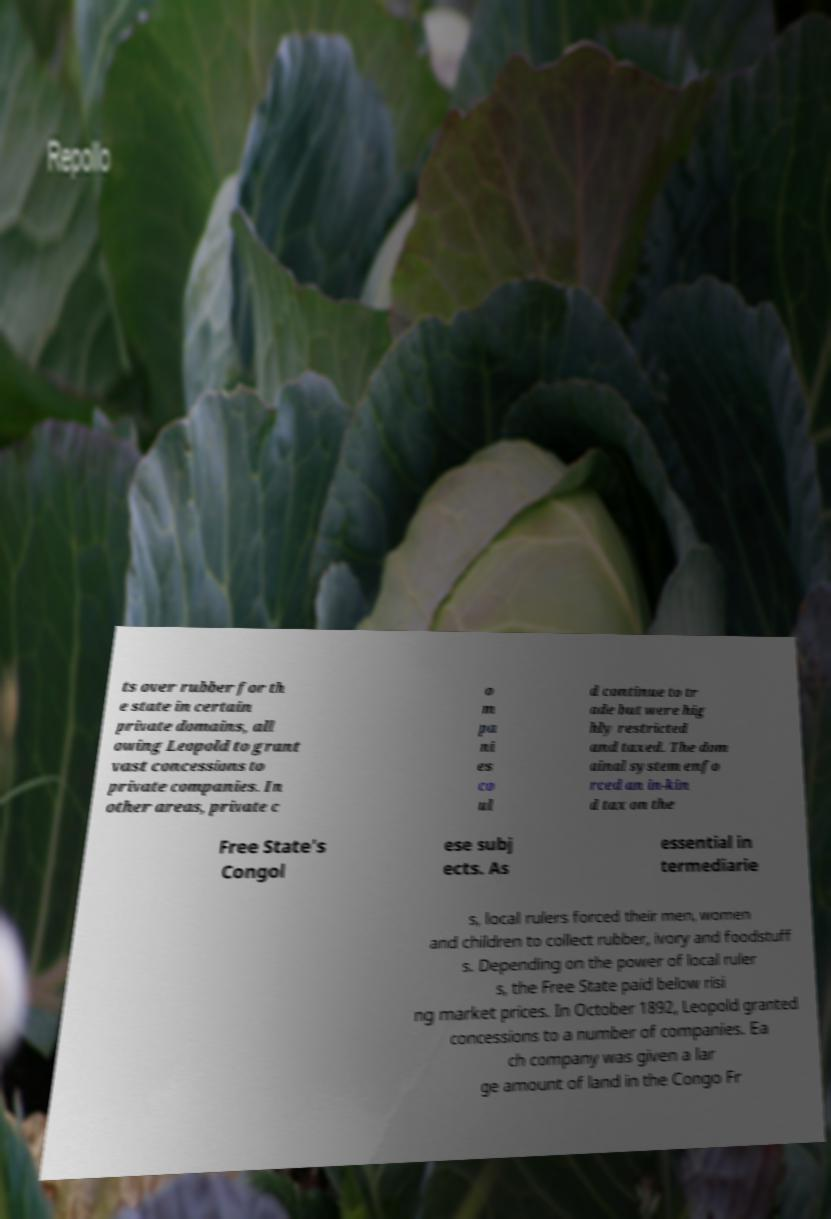Can you accurately transcribe the text from the provided image for me? ts over rubber for th e state in certain private domains, all owing Leopold to grant vast concessions to private companies. In other areas, private c o m pa ni es co ul d continue to tr ade but were hig hly restricted and taxed. The dom ainal system enfo rced an in-kin d tax on the Free State's Congol ese subj ects. As essential in termediarie s, local rulers forced their men, women and children to collect rubber, ivory and foodstuff s. Depending on the power of local ruler s, the Free State paid below risi ng market prices. In October 1892, Leopold granted concessions to a number of companies. Ea ch company was given a lar ge amount of land in the Congo Fr 